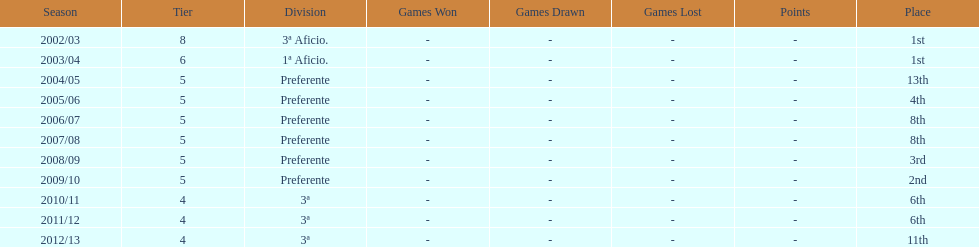In what year did the team achieve the same place as 2010/11? 2011/12. 